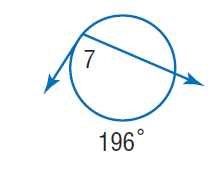Question: Find \angle 7.
Choices:
A. 41
B. 82
C. 98
D. 186
Answer with the letter. Answer: C 